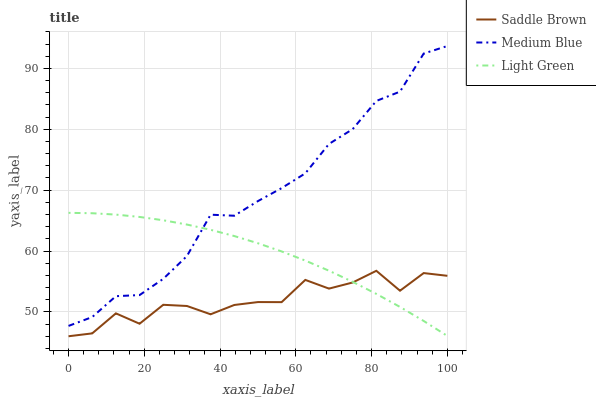Does Saddle Brown have the minimum area under the curve?
Answer yes or no. Yes. Does Medium Blue have the maximum area under the curve?
Answer yes or no. Yes. Does Light Green have the minimum area under the curve?
Answer yes or no. No. Does Light Green have the maximum area under the curve?
Answer yes or no. No. Is Light Green the smoothest?
Answer yes or no. Yes. Is Saddle Brown the roughest?
Answer yes or no. Yes. Is Saddle Brown the smoothest?
Answer yes or no. No. Is Light Green the roughest?
Answer yes or no. No. Does Saddle Brown have the lowest value?
Answer yes or no. Yes. Does Light Green have the lowest value?
Answer yes or no. No. Does Medium Blue have the highest value?
Answer yes or no. Yes. Does Light Green have the highest value?
Answer yes or no. No. Is Saddle Brown less than Medium Blue?
Answer yes or no. Yes. Is Medium Blue greater than Saddle Brown?
Answer yes or no. Yes. Does Saddle Brown intersect Light Green?
Answer yes or no. Yes. Is Saddle Brown less than Light Green?
Answer yes or no. No. Is Saddle Brown greater than Light Green?
Answer yes or no. No. Does Saddle Brown intersect Medium Blue?
Answer yes or no. No. 